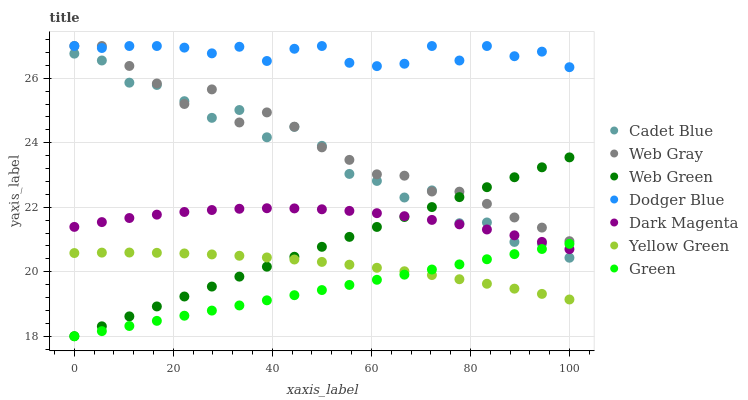Does Green have the minimum area under the curve?
Answer yes or no. Yes. Does Dodger Blue have the maximum area under the curve?
Answer yes or no. Yes. Does Dark Magenta have the minimum area under the curve?
Answer yes or no. No. Does Dark Magenta have the maximum area under the curve?
Answer yes or no. No. Is Web Green the smoothest?
Answer yes or no. Yes. Is Cadet Blue the roughest?
Answer yes or no. Yes. Is Dark Magenta the smoothest?
Answer yes or no. No. Is Dark Magenta the roughest?
Answer yes or no. No. Does Web Green have the lowest value?
Answer yes or no. Yes. Does Dark Magenta have the lowest value?
Answer yes or no. No. Does Dodger Blue have the highest value?
Answer yes or no. Yes. Does Dark Magenta have the highest value?
Answer yes or no. No. Is Green less than Web Gray?
Answer yes or no. Yes. Is Dodger Blue greater than Dark Magenta?
Answer yes or no. Yes. Does Cadet Blue intersect Dark Magenta?
Answer yes or no. Yes. Is Cadet Blue less than Dark Magenta?
Answer yes or no. No. Is Cadet Blue greater than Dark Magenta?
Answer yes or no. No. Does Green intersect Web Gray?
Answer yes or no. No. 